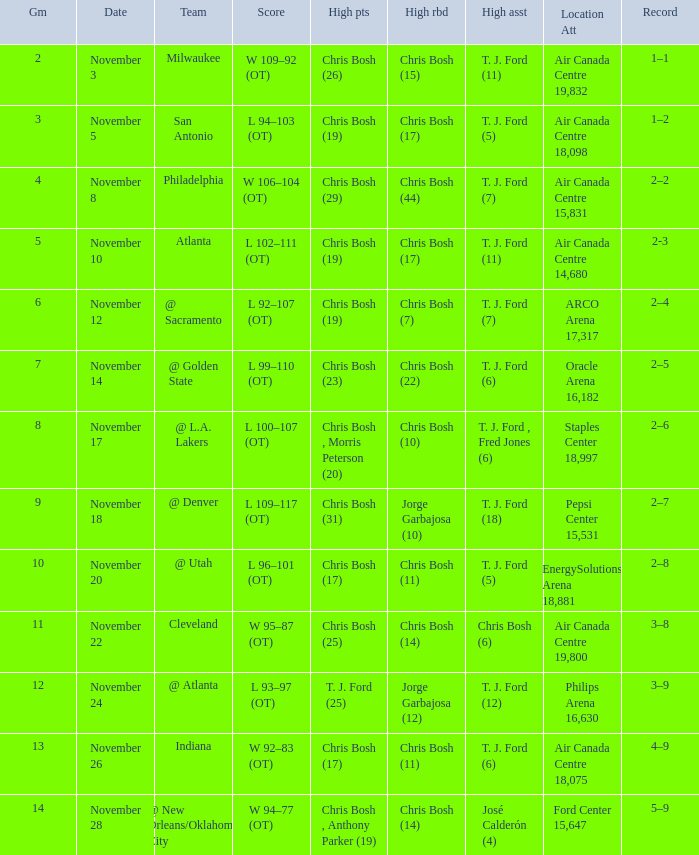Who scored the most points in game 4? Chris Bosh (29). 